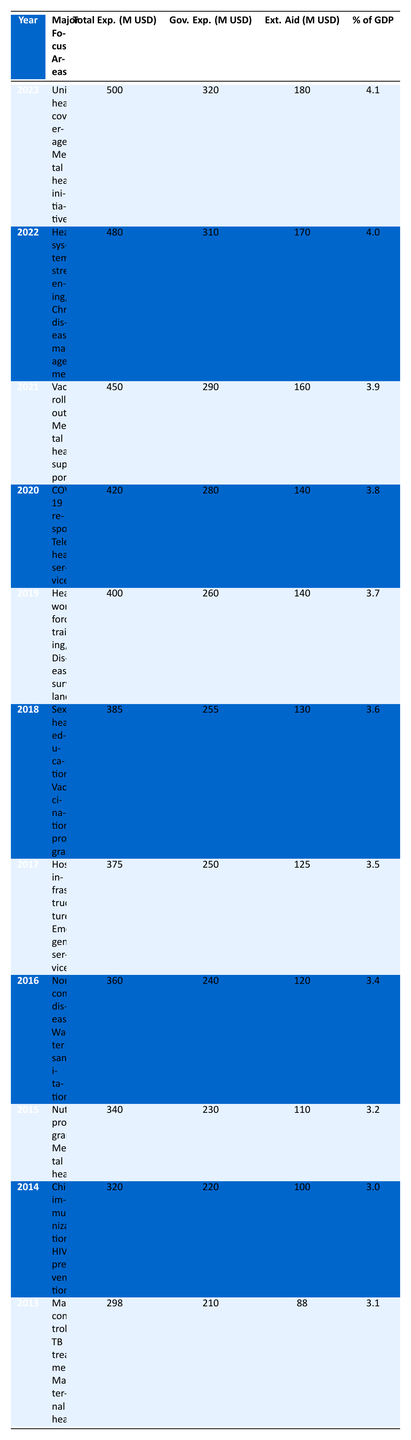What was the total public health expenditure in Papua New Guinea in 2020? In the table, I locate the row for the year 2020, which lists the total expenditure as 420 million USD.
Answer: 420 million USD Which year had the highest government expenditure on public health? Scanning the table, 2023 shows the highest government expenditure of 320 million USD compared to previous years.
Answer: 2023 What is the percentage of GDP for public health expenditure in 2018? Referring to the year 2018 in the table, I find that the percentage of GDP for public health expenditure is 3.6.
Answer: 3.6 What was the average total public health expenditure from 2013 to 2022? To find the average, I sum the total expenditures from 2013 (298) to 2022 (480), resulting in a total of 3,534 million USD. Dividing this by 10 gives an average of 353.4 million USD.
Answer: 353.4 million USD Is external aid more than government expenditure in 2014? Looking at the row for 2014, the external aid is 100 million USD, while government expenditure is 220 million USD; therefore, external aid is not more than government expenditure.
Answer: No Which year saw an increase in both government expenditure and external aid compared to the previous year? Comparing each year, from 2020 to 2021, both government expenditure (from 280 to 290 million USD) and external aid (from 140 to 160 million USD) increased, indicating this is the year.
Answer: 2021 What was the total amount of external aid in 2019 and 2020 combined? Looking at the table, the external aid in 2019 is 140 million USD and in 2020 is also 140 million USD. Adding these together yields a total of 280 million USD.
Answer: 280 million USD How much did the percentage of GDP increase from 2013 to 2023? The percentage of GDP in 2013 was 3.1 and in 2023 it is 4.1. The increase is calculated as 4.1 - 3.1 = 1.0.
Answer: 1.0 Was there a focus on mental health initiatives in 2015? Upon examining the major focus areas for 2015, it is clear that mental health was included as one of the focus areas.
Answer: Yes 